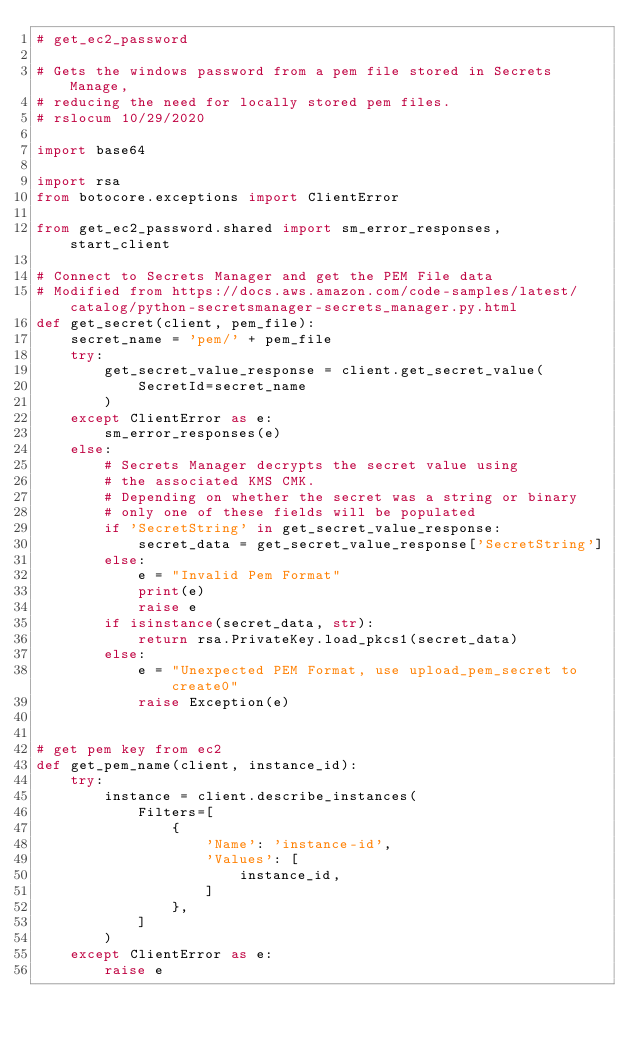Convert code to text. <code><loc_0><loc_0><loc_500><loc_500><_Python_># get_ec2_password

# Gets the windows password from a pem file stored in Secrets Manage,
# reducing the need for locally stored pem files.
# rslocum 10/29/2020

import base64

import rsa
from botocore.exceptions import ClientError

from get_ec2_password.shared import sm_error_responses, start_client

# Connect to Secrets Manager and get the PEM File data
# Modified from https://docs.aws.amazon.com/code-samples/latest/catalog/python-secretsmanager-secrets_manager.py.html
def get_secret(client, pem_file):
    secret_name = 'pem/' + pem_file
    try:
        get_secret_value_response = client.get_secret_value(
            SecretId=secret_name
        )
    except ClientError as e:
        sm_error_responses(e)
    else:
        # Secrets Manager decrypts the secret value using
        # the associated KMS CMK.
        # Depending on whether the secret was a string or binary
        # only one of these fields will be populated
        if 'SecretString' in get_secret_value_response:
            secret_data = get_secret_value_response['SecretString']
        else:
            e = "Invalid Pem Format"
            print(e)
            raise e
        if isinstance(secret_data, str):
            return rsa.PrivateKey.load_pkcs1(secret_data)
        else:
            e = "Unexpected PEM Format, use upload_pem_secret to create0"
            raise Exception(e)


# get pem key from ec2
def get_pem_name(client, instance_id):
    try:
        instance = client.describe_instances(
            Filters=[
                {
                    'Name': 'instance-id',
                    'Values': [
                        instance_id,
                    ]
                },
            ]
        )
    except ClientError as e:
        raise e</code> 